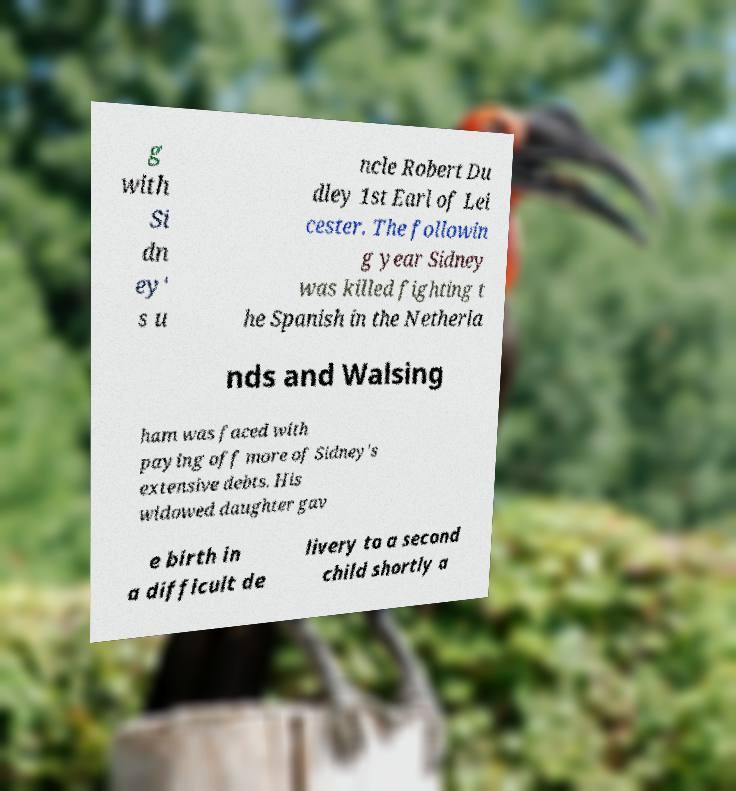Could you extract and type out the text from this image? g with Si dn ey' s u ncle Robert Du dley 1st Earl of Lei cester. The followin g year Sidney was killed fighting t he Spanish in the Netherla nds and Walsing ham was faced with paying off more of Sidney's extensive debts. His widowed daughter gav e birth in a difficult de livery to a second child shortly a 